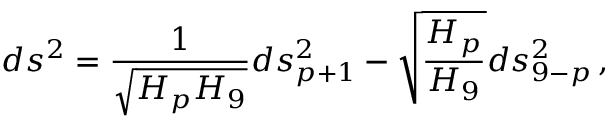<formula> <loc_0><loc_0><loc_500><loc_500>d s ^ { 2 } = { \frac { 1 } { \sqrt { H _ { p } H _ { 9 } } } } d s _ { p + 1 } ^ { 2 } - \sqrt { { \frac { H _ { p } } { H _ { 9 } } } } d s _ { 9 - p } ^ { 2 } \, ,</formula> 